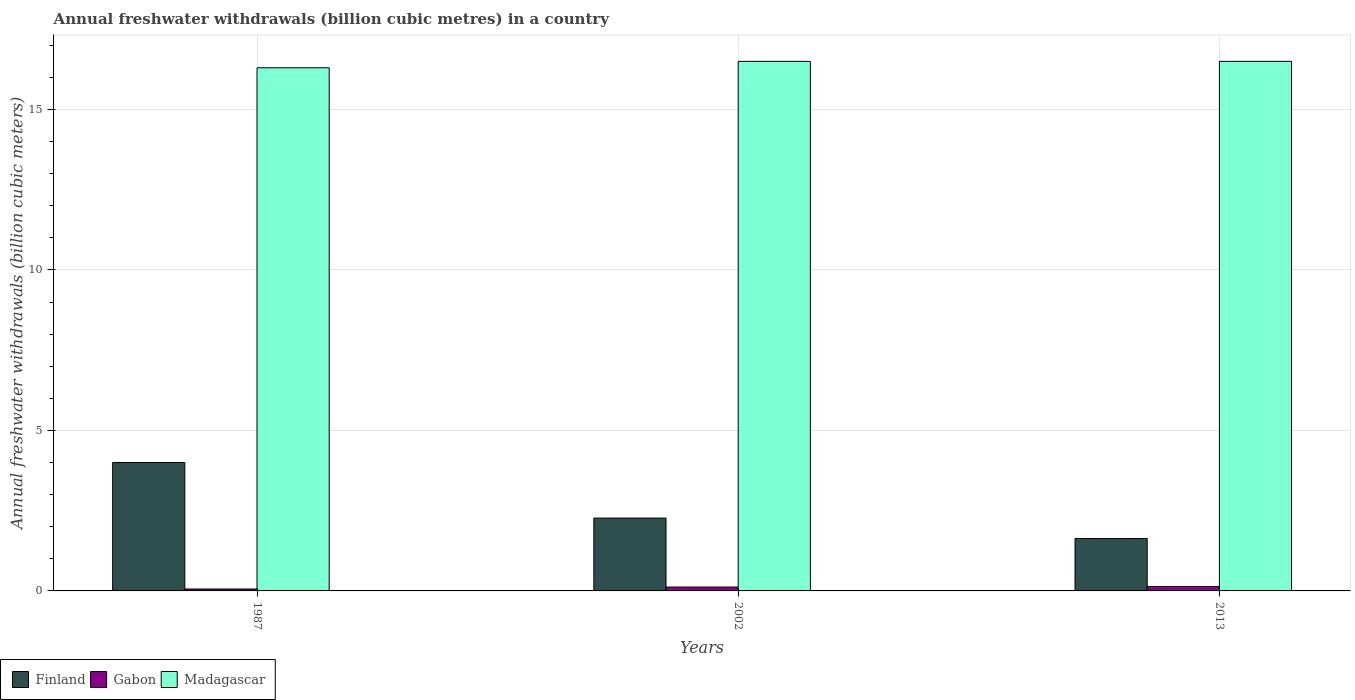How many groups of bars are there?
Offer a very short reply. 3. Are the number of bars per tick equal to the number of legend labels?
Ensure brevity in your answer.  Yes. How many bars are there on the 1st tick from the left?
Offer a terse response. 3. What is the label of the 1st group of bars from the left?
Provide a succinct answer. 1987. In how many cases, is the number of bars for a given year not equal to the number of legend labels?
Keep it short and to the point. 0. Across all years, what is the minimum annual freshwater withdrawals in Madagascar?
Provide a short and direct response. 16.3. In which year was the annual freshwater withdrawals in Finland maximum?
Ensure brevity in your answer.  1987. In which year was the annual freshwater withdrawals in Gabon minimum?
Provide a short and direct response. 1987. What is the total annual freshwater withdrawals in Finland in the graph?
Keep it short and to the point. 7.9. What is the difference between the annual freshwater withdrawals in Gabon in 2002 and that in 2013?
Your answer should be very brief. -0.02. What is the difference between the annual freshwater withdrawals in Gabon in 1987 and the annual freshwater withdrawals in Madagascar in 2002?
Offer a very short reply. -16.44. What is the average annual freshwater withdrawals in Finland per year?
Your answer should be very brief. 2.63. In the year 2002, what is the difference between the annual freshwater withdrawals in Madagascar and annual freshwater withdrawals in Gabon?
Provide a short and direct response. 16.38. In how many years, is the annual freshwater withdrawals in Gabon greater than 2 billion cubic meters?
Offer a very short reply. 0. What is the ratio of the annual freshwater withdrawals in Finland in 2002 to that in 2013?
Provide a succinct answer. 1.39. Is the difference between the annual freshwater withdrawals in Madagascar in 1987 and 2002 greater than the difference between the annual freshwater withdrawals in Gabon in 1987 and 2002?
Provide a succinct answer. No. What is the difference between the highest and the second highest annual freshwater withdrawals in Gabon?
Your answer should be very brief. 0.02. What is the difference between the highest and the lowest annual freshwater withdrawals in Gabon?
Provide a succinct answer. 0.08. In how many years, is the annual freshwater withdrawals in Madagascar greater than the average annual freshwater withdrawals in Madagascar taken over all years?
Provide a succinct answer. 2. What does the 2nd bar from the left in 2013 represents?
Keep it short and to the point. Gabon. What does the 1st bar from the right in 2013 represents?
Offer a terse response. Madagascar. Are all the bars in the graph horizontal?
Make the answer very short. No. How many years are there in the graph?
Keep it short and to the point. 3. Are the values on the major ticks of Y-axis written in scientific E-notation?
Offer a terse response. No. Where does the legend appear in the graph?
Ensure brevity in your answer.  Bottom left. How many legend labels are there?
Provide a succinct answer. 3. How are the legend labels stacked?
Offer a terse response. Horizontal. What is the title of the graph?
Your answer should be very brief. Annual freshwater withdrawals (billion cubic metres) in a country. Does "Mongolia" appear as one of the legend labels in the graph?
Your answer should be very brief. No. What is the label or title of the Y-axis?
Your response must be concise. Annual freshwater withdrawals (billion cubic meters). What is the Annual freshwater withdrawals (billion cubic meters) of Finland in 2002?
Offer a very short reply. 2.27. What is the Annual freshwater withdrawals (billion cubic meters) in Gabon in 2002?
Make the answer very short. 0.12. What is the Annual freshwater withdrawals (billion cubic meters) in Madagascar in 2002?
Give a very brief answer. 16.5. What is the Annual freshwater withdrawals (billion cubic meters) of Finland in 2013?
Offer a very short reply. 1.63. What is the Annual freshwater withdrawals (billion cubic meters) in Gabon in 2013?
Provide a succinct answer. 0.14. What is the Annual freshwater withdrawals (billion cubic meters) in Madagascar in 2013?
Your response must be concise. 16.5. Across all years, what is the maximum Annual freshwater withdrawals (billion cubic meters) in Finland?
Ensure brevity in your answer.  4. Across all years, what is the maximum Annual freshwater withdrawals (billion cubic meters) of Gabon?
Keep it short and to the point. 0.14. Across all years, what is the minimum Annual freshwater withdrawals (billion cubic meters) of Finland?
Provide a succinct answer. 1.63. Across all years, what is the minimum Annual freshwater withdrawals (billion cubic meters) of Gabon?
Your response must be concise. 0.06. What is the total Annual freshwater withdrawals (billion cubic meters) in Finland in the graph?
Your answer should be compact. 7.9. What is the total Annual freshwater withdrawals (billion cubic meters) of Gabon in the graph?
Offer a terse response. 0.32. What is the total Annual freshwater withdrawals (billion cubic meters) in Madagascar in the graph?
Keep it short and to the point. 49.3. What is the difference between the Annual freshwater withdrawals (billion cubic meters) in Finland in 1987 and that in 2002?
Ensure brevity in your answer.  1.73. What is the difference between the Annual freshwater withdrawals (billion cubic meters) of Gabon in 1987 and that in 2002?
Ensure brevity in your answer.  -0.06. What is the difference between the Annual freshwater withdrawals (billion cubic meters) in Madagascar in 1987 and that in 2002?
Your answer should be very brief. -0.2. What is the difference between the Annual freshwater withdrawals (billion cubic meters) of Finland in 1987 and that in 2013?
Your answer should be very brief. 2.37. What is the difference between the Annual freshwater withdrawals (billion cubic meters) in Gabon in 1987 and that in 2013?
Offer a very short reply. -0.08. What is the difference between the Annual freshwater withdrawals (billion cubic meters) in Madagascar in 1987 and that in 2013?
Keep it short and to the point. -0.2. What is the difference between the Annual freshwater withdrawals (billion cubic meters) of Finland in 2002 and that in 2013?
Ensure brevity in your answer.  0.64. What is the difference between the Annual freshwater withdrawals (billion cubic meters) of Gabon in 2002 and that in 2013?
Offer a terse response. -0.02. What is the difference between the Annual freshwater withdrawals (billion cubic meters) of Finland in 1987 and the Annual freshwater withdrawals (billion cubic meters) of Gabon in 2002?
Offer a very short reply. 3.88. What is the difference between the Annual freshwater withdrawals (billion cubic meters) of Gabon in 1987 and the Annual freshwater withdrawals (billion cubic meters) of Madagascar in 2002?
Provide a short and direct response. -16.44. What is the difference between the Annual freshwater withdrawals (billion cubic meters) in Finland in 1987 and the Annual freshwater withdrawals (billion cubic meters) in Gabon in 2013?
Your response must be concise. 3.86. What is the difference between the Annual freshwater withdrawals (billion cubic meters) in Finland in 1987 and the Annual freshwater withdrawals (billion cubic meters) in Madagascar in 2013?
Offer a terse response. -12.5. What is the difference between the Annual freshwater withdrawals (billion cubic meters) of Gabon in 1987 and the Annual freshwater withdrawals (billion cubic meters) of Madagascar in 2013?
Offer a very short reply. -16.44. What is the difference between the Annual freshwater withdrawals (billion cubic meters) of Finland in 2002 and the Annual freshwater withdrawals (billion cubic meters) of Gabon in 2013?
Ensure brevity in your answer.  2.13. What is the difference between the Annual freshwater withdrawals (billion cubic meters) in Finland in 2002 and the Annual freshwater withdrawals (billion cubic meters) in Madagascar in 2013?
Your response must be concise. -14.23. What is the difference between the Annual freshwater withdrawals (billion cubic meters) in Gabon in 2002 and the Annual freshwater withdrawals (billion cubic meters) in Madagascar in 2013?
Ensure brevity in your answer.  -16.38. What is the average Annual freshwater withdrawals (billion cubic meters) in Finland per year?
Keep it short and to the point. 2.63. What is the average Annual freshwater withdrawals (billion cubic meters) in Gabon per year?
Make the answer very short. 0.11. What is the average Annual freshwater withdrawals (billion cubic meters) in Madagascar per year?
Your answer should be compact. 16.43. In the year 1987, what is the difference between the Annual freshwater withdrawals (billion cubic meters) of Finland and Annual freshwater withdrawals (billion cubic meters) of Gabon?
Your answer should be very brief. 3.94. In the year 1987, what is the difference between the Annual freshwater withdrawals (billion cubic meters) of Finland and Annual freshwater withdrawals (billion cubic meters) of Madagascar?
Offer a terse response. -12.3. In the year 1987, what is the difference between the Annual freshwater withdrawals (billion cubic meters) in Gabon and Annual freshwater withdrawals (billion cubic meters) in Madagascar?
Your answer should be very brief. -16.24. In the year 2002, what is the difference between the Annual freshwater withdrawals (billion cubic meters) of Finland and Annual freshwater withdrawals (billion cubic meters) of Gabon?
Offer a very short reply. 2.15. In the year 2002, what is the difference between the Annual freshwater withdrawals (billion cubic meters) in Finland and Annual freshwater withdrawals (billion cubic meters) in Madagascar?
Keep it short and to the point. -14.23. In the year 2002, what is the difference between the Annual freshwater withdrawals (billion cubic meters) in Gabon and Annual freshwater withdrawals (billion cubic meters) in Madagascar?
Provide a short and direct response. -16.38. In the year 2013, what is the difference between the Annual freshwater withdrawals (billion cubic meters) in Finland and Annual freshwater withdrawals (billion cubic meters) in Gabon?
Your answer should be compact. 1.49. In the year 2013, what is the difference between the Annual freshwater withdrawals (billion cubic meters) in Finland and Annual freshwater withdrawals (billion cubic meters) in Madagascar?
Your answer should be very brief. -14.87. In the year 2013, what is the difference between the Annual freshwater withdrawals (billion cubic meters) in Gabon and Annual freshwater withdrawals (billion cubic meters) in Madagascar?
Give a very brief answer. -16.36. What is the ratio of the Annual freshwater withdrawals (billion cubic meters) of Finland in 1987 to that in 2002?
Make the answer very short. 1.76. What is the ratio of the Annual freshwater withdrawals (billion cubic meters) of Gabon in 1987 to that in 2002?
Give a very brief answer. 0.5. What is the ratio of the Annual freshwater withdrawals (billion cubic meters) in Madagascar in 1987 to that in 2002?
Provide a succinct answer. 0.99. What is the ratio of the Annual freshwater withdrawals (billion cubic meters) in Finland in 1987 to that in 2013?
Offer a very short reply. 2.45. What is the ratio of the Annual freshwater withdrawals (billion cubic meters) of Gabon in 1987 to that in 2013?
Offer a very short reply. 0.43. What is the ratio of the Annual freshwater withdrawals (billion cubic meters) of Madagascar in 1987 to that in 2013?
Offer a terse response. 0.99. What is the ratio of the Annual freshwater withdrawals (billion cubic meters) in Finland in 2002 to that in 2013?
Your response must be concise. 1.39. What is the ratio of the Annual freshwater withdrawals (billion cubic meters) in Gabon in 2002 to that in 2013?
Your answer should be compact. 0.86. What is the ratio of the Annual freshwater withdrawals (billion cubic meters) in Madagascar in 2002 to that in 2013?
Offer a terse response. 1. What is the difference between the highest and the second highest Annual freshwater withdrawals (billion cubic meters) in Finland?
Offer a terse response. 1.73. What is the difference between the highest and the second highest Annual freshwater withdrawals (billion cubic meters) in Gabon?
Offer a terse response. 0.02. What is the difference between the highest and the lowest Annual freshwater withdrawals (billion cubic meters) of Finland?
Offer a terse response. 2.37. What is the difference between the highest and the lowest Annual freshwater withdrawals (billion cubic meters) in Gabon?
Offer a terse response. 0.08. What is the difference between the highest and the lowest Annual freshwater withdrawals (billion cubic meters) of Madagascar?
Provide a succinct answer. 0.2. 